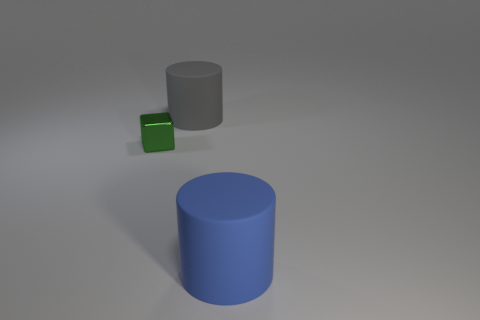Subtract all purple blocks. Subtract all brown balls. How many blocks are left? 1 Add 2 large yellow things. How many objects exist? 5 Subtract all cubes. How many objects are left? 2 Subtract all gray cylinders. Subtract all large blue matte things. How many objects are left? 1 Add 2 big matte cylinders. How many big matte cylinders are left? 4 Add 1 large blue rubber objects. How many large blue rubber objects exist? 2 Subtract 0 cyan cylinders. How many objects are left? 3 